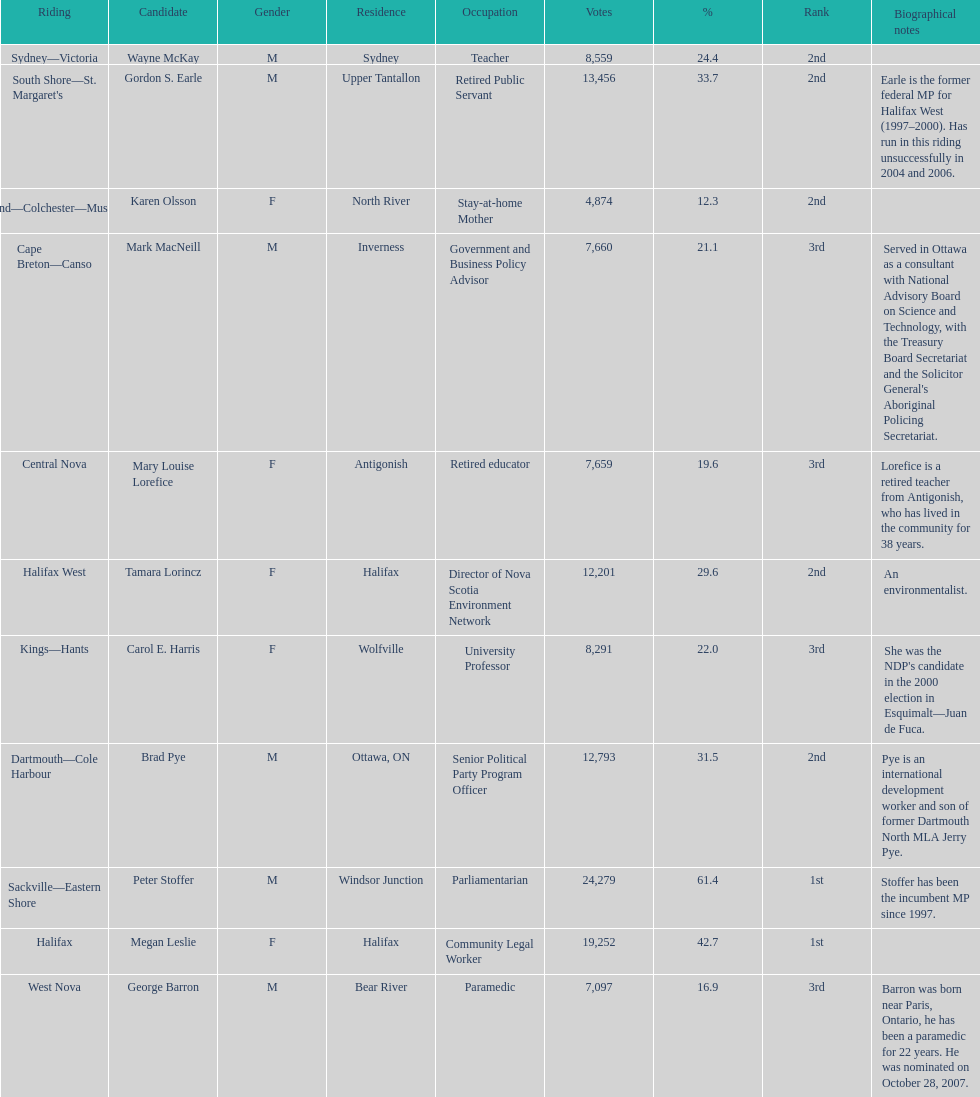How many of the candidates were females? 5. Help me parse the entirety of this table. {'header': ['Riding', 'Candidate', 'Gender', 'Residence', 'Occupation', 'Votes', '%', 'Rank', 'Biographical notes'], 'rows': [['Sydney—Victoria', 'Wayne McKay', 'M', 'Sydney', 'Teacher', '8,559', '24.4', '2nd', ''], ["South Shore—St. Margaret's", 'Gordon S. Earle', 'M', 'Upper Tantallon', 'Retired Public Servant', '13,456', '33.7', '2nd', 'Earle is the former federal MP for Halifax West (1997–2000). Has run in this riding unsuccessfully in 2004 and 2006.'], ['Cumberland—Colchester—Musquodoboit Valley', 'Karen Olsson', 'F', 'North River', 'Stay-at-home Mother', '4,874', '12.3', '2nd', ''], ['Cape Breton—Canso', 'Mark MacNeill', 'M', 'Inverness', 'Government and Business Policy Advisor', '7,660', '21.1', '3rd', "Served in Ottawa as a consultant with National Advisory Board on Science and Technology, with the Treasury Board Secretariat and the Solicitor General's Aboriginal Policing Secretariat."], ['Central Nova', 'Mary Louise Lorefice', 'F', 'Antigonish', 'Retired educator', '7,659', '19.6', '3rd', 'Lorefice is a retired teacher from Antigonish, who has lived in the community for 38 years.'], ['Halifax West', 'Tamara Lorincz', 'F', 'Halifax', 'Director of Nova Scotia Environment Network', '12,201', '29.6', '2nd', 'An environmentalist.'], ['Kings—Hants', 'Carol E. Harris', 'F', 'Wolfville', 'University Professor', '8,291', '22.0', '3rd', "She was the NDP's candidate in the 2000 election in Esquimalt—Juan de Fuca."], ['Dartmouth—Cole Harbour', 'Brad Pye', 'M', 'Ottawa, ON', 'Senior Political Party Program Officer', '12,793', '31.5', '2nd', 'Pye is an international development worker and son of former Dartmouth North MLA Jerry Pye.'], ['Sackville—Eastern Shore', 'Peter Stoffer', 'M', 'Windsor Junction', 'Parliamentarian', '24,279', '61.4', '1st', 'Stoffer has been the incumbent MP since 1997.'], ['Halifax', 'Megan Leslie', 'F', 'Halifax', 'Community Legal Worker', '19,252', '42.7', '1st', ''], ['West Nova', 'George Barron', 'M', 'Bear River', 'Paramedic', '7,097', '16.9', '3rd', 'Barron was born near Paris, Ontario, he has been a paramedic for 22 years. He was nominated on October 28, 2007.']]} 